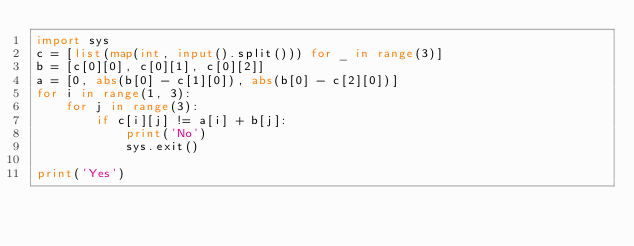<code> <loc_0><loc_0><loc_500><loc_500><_Python_>import sys
c = [list(map(int, input().split())) for _ in range(3)]
b = [c[0][0], c[0][1], c[0][2]]
a = [0, abs(b[0] - c[1][0]), abs(b[0] - c[2][0])]
for i in range(1, 3):
    for j in range(3):
        if c[i][j] != a[i] + b[j]:
            print('No')
            sys.exit()

print('Yes')</code> 